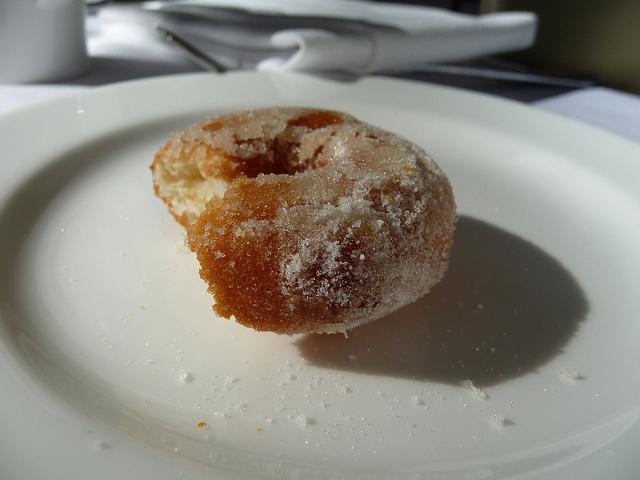Is this a donut or a bagel?
Answer briefly. Donut. What type of food is on the plate?
Concise answer only. Donut. Is this sugary?
Quick response, please. Yes. Did someone eat half a donut?
Give a very brief answer. Yes. Is there glaze on the doughnut?
Keep it brief. No. What is on the plate?
Be succinct. Donut. What kind of donut is this?
Quick response, please. Sugar. 